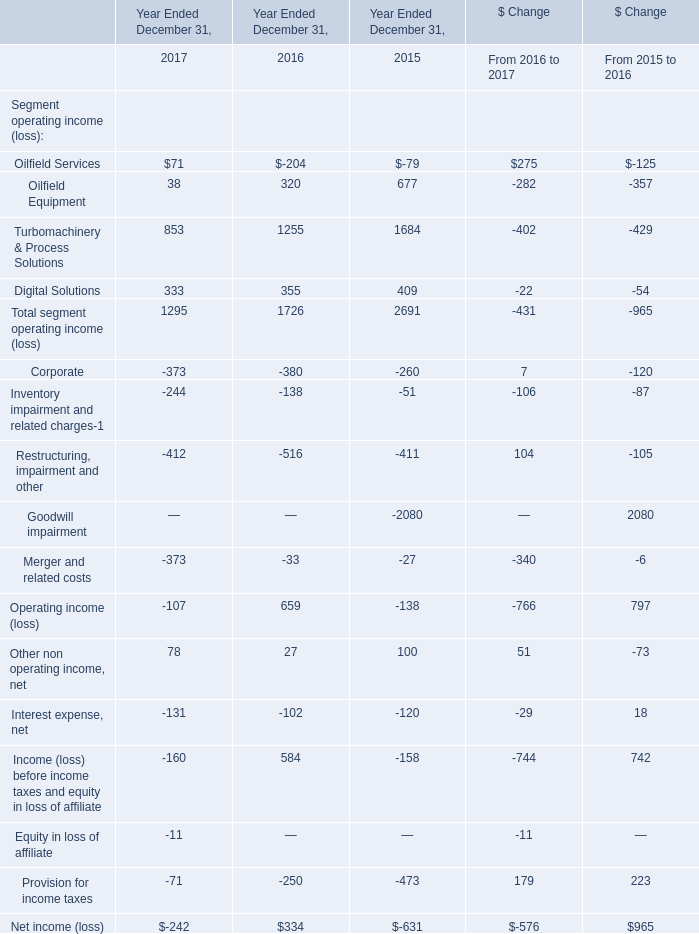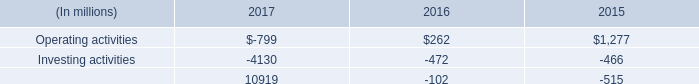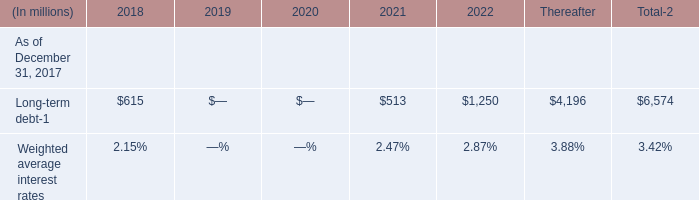How many element name keeps increasing between 2017 and 2016? 
Answer: 4. 